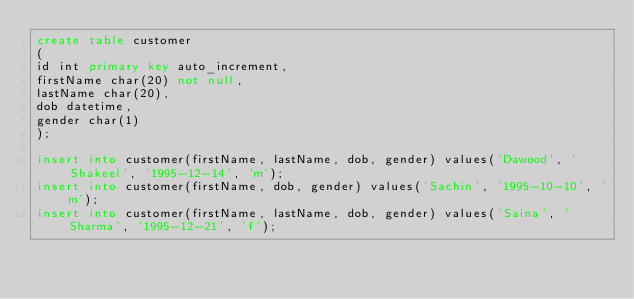Convert code to text. <code><loc_0><loc_0><loc_500><loc_500><_SQL_>create table customer
(
id int primary key auto_increment,
firstName char(20) not null,
lastName char(20),
dob datetime,
gender char(1)
);

insert into customer(firstName, lastName, dob, gender) values('Dawood', 'Shakeel', '1995-12-14', 'm');
insert into customer(firstName, dob, gender) values('Sachin', '1995-10-10', 'm');
insert into customer(firstName, lastName, dob, gender) values('Saina', 'Sharma', '1995-12-21', 'f');</code> 